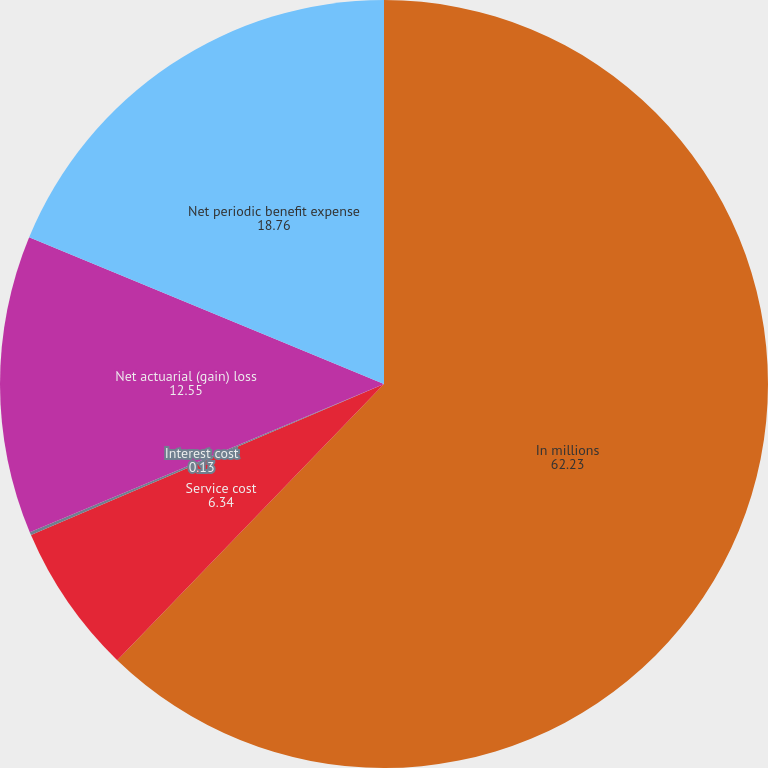Convert chart. <chart><loc_0><loc_0><loc_500><loc_500><pie_chart><fcel>In millions<fcel>Service cost<fcel>Interest cost<fcel>Net actuarial (gain) loss<fcel>Net periodic benefit expense<nl><fcel>62.23%<fcel>6.34%<fcel>0.13%<fcel>12.55%<fcel>18.76%<nl></chart> 